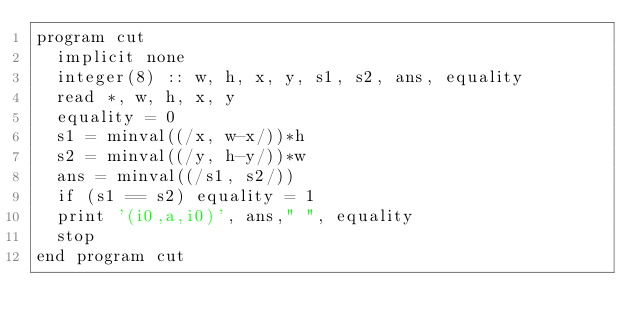Convert code to text. <code><loc_0><loc_0><loc_500><loc_500><_FORTRAN_>program cut
  implicit none
  integer(8) :: w, h, x, y, s1, s2, ans, equality
  read *, w, h, x, y
  equality = 0
  s1 = minval((/x, w-x/))*h
  s2 = minval((/y, h-y/))*w 
  ans = minval((/s1, s2/))
  if (s1 == s2) equality = 1 
  print '(i0,a,i0)', ans," ", equality
  stop
end program cut
</code> 